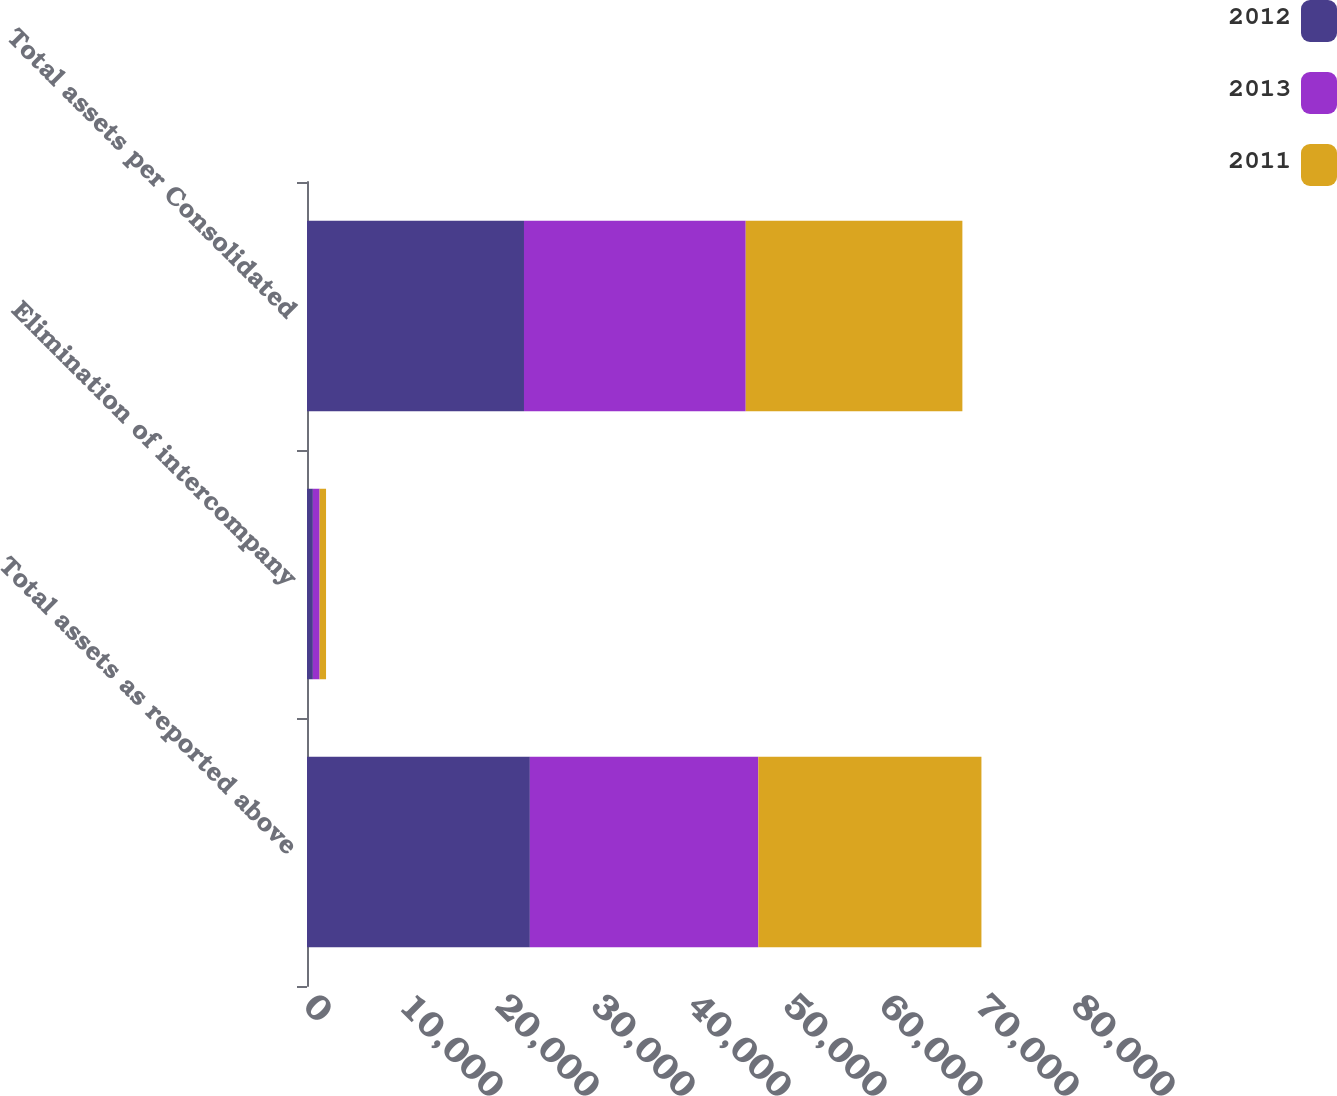Convert chart to OTSL. <chart><loc_0><loc_0><loc_500><loc_500><stacked_bar_chart><ecel><fcel>Total assets as reported above<fcel>Elimination of intercompany<fcel>Total assets per Consolidated<nl><fcel>2012<fcel>23215<fcel>612<fcel>22603<nl><fcel>2013<fcel>23797<fcel>700<fcel>23097<nl><fcel>2011<fcel>23241<fcel>672<fcel>22569<nl></chart> 